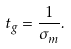<formula> <loc_0><loc_0><loc_500><loc_500>t _ { g } = \frac { 1 } { \sigma _ { m } } .</formula> 